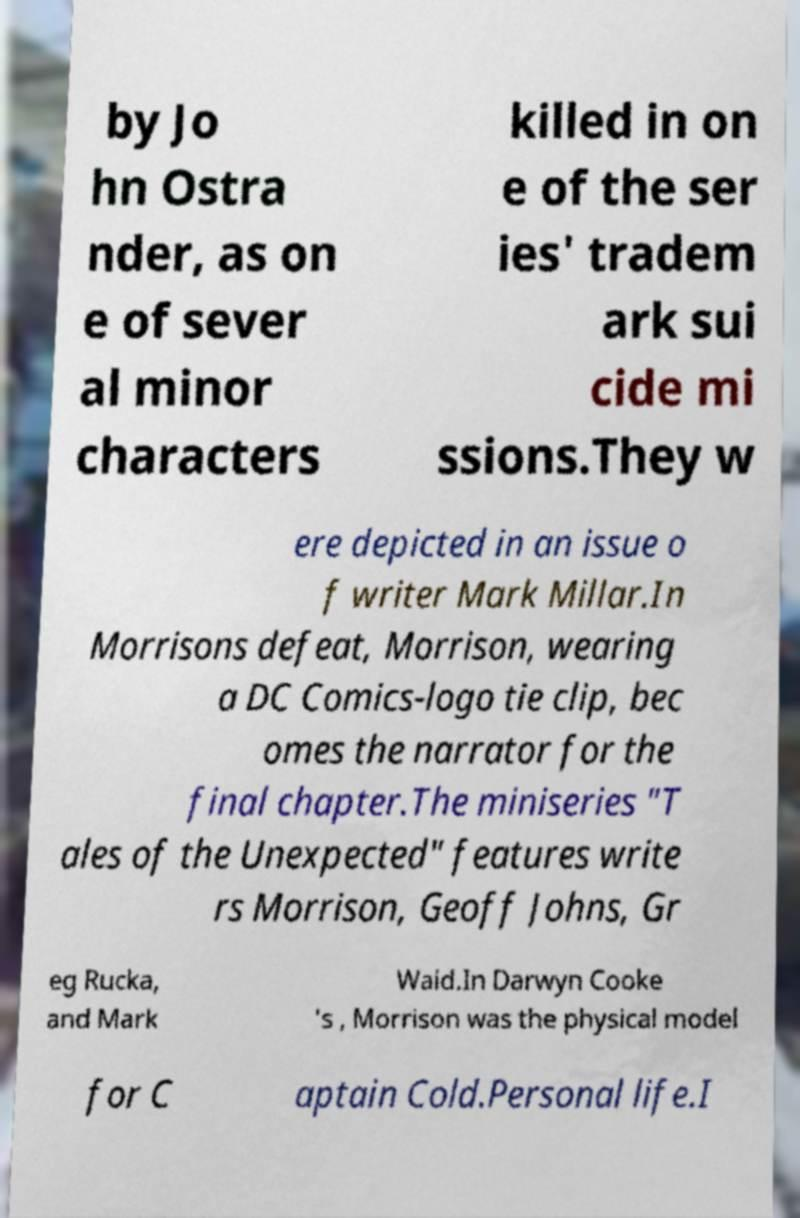There's text embedded in this image that I need extracted. Can you transcribe it verbatim? by Jo hn Ostra nder, as on e of sever al minor characters killed in on e of the ser ies' tradem ark sui cide mi ssions.They w ere depicted in an issue o f writer Mark Millar.In Morrisons defeat, Morrison, wearing a DC Comics-logo tie clip, bec omes the narrator for the final chapter.The miniseries "T ales of the Unexpected" features write rs Morrison, Geoff Johns, Gr eg Rucka, and Mark Waid.In Darwyn Cooke 's , Morrison was the physical model for C aptain Cold.Personal life.I 